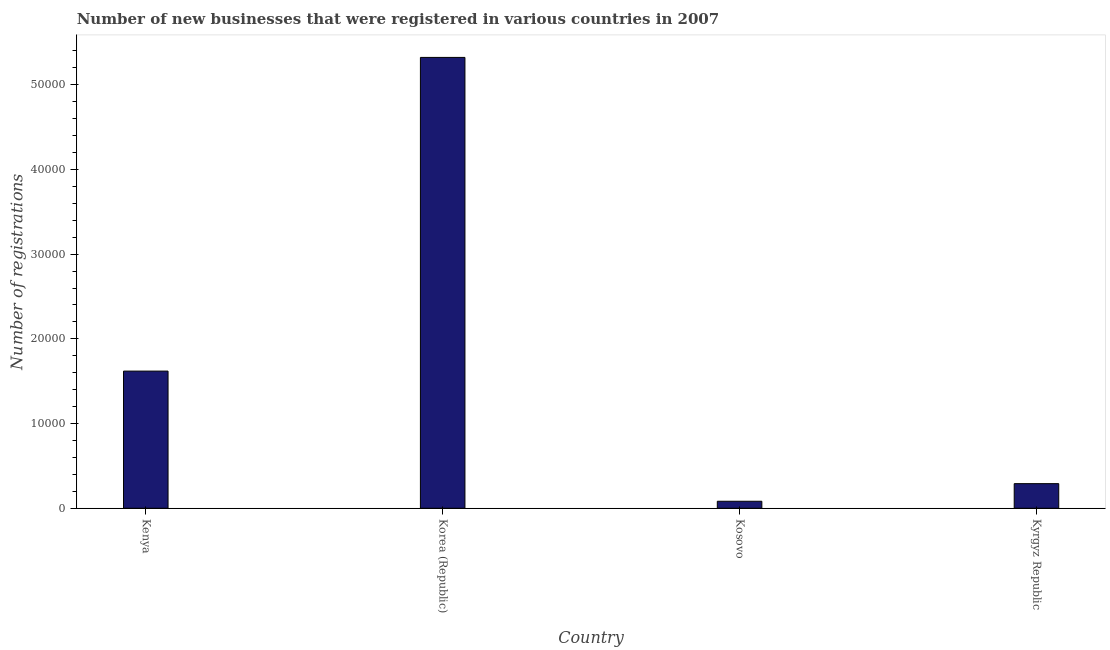What is the title of the graph?
Offer a terse response. Number of new businesses that were registered in various countries in 2007. What is the label or title of the X-axis?
Ensure brevity in your answer.  Country. What is the label or title of the Y-axis?
Give a very brief answer. Number of registrations. What is the number of new business registrations in Kenya?
Make the answer very short. 1.62e+04. Across all countries, what is the maximum number of new business registrations?
Your answer should be very brief. 5.32e+04. Across all countries, what is the minimum number of new business registrations?
Your answer should be very brief. 827. In which country was the number of new business registrations maximum?
Provide a short and direct response. Korea (Republic). In which country was the number of new business registrations minimum?
Provide a short and direct response. Kosovo. What is the sum of the number of new business registrations?
Your answer should be compact. 7.32e+04. What is the difference between the number of new business registrations in Korea (Republic) and Kyrgyz Republic?
Your response must be concise. 5.03e+04. What is the average number of new business registrations per country?
Make the answer very short. 1.83e+04. What is the median number of new business registrations?
Your answer should be compact. 9549.5. In how many countries, is the number of new business registrations greater than 6000 ?
Your answer should be very brief. 2. What is the ratio of the number of new business registrations in Kosovo to that in Kyrgyz Republic?
Offer a terse response. 0.28. Is the number of new business registrations in Kenya less than that in Kyrgyz Republic?
Your response must be concise. No. Is the difference between the number of new business registrations in Kenya and Korea (Republic) greater than the difference between any two countries?
Offer a terse response. No. What is the difference between the highest and the second highest number of new business registrations?
Provide a short and direct response. 3.70e+04. What is the difference between the highest and the lowest number of new business registrations?
Make the answer very short. 5.24e+04. How many bars are there?
Your response must be concise. 4. Are the values on the major ticks of Y-axis written in scientific E-notation?
Offer a very short reply. No. What is the Number of registrations of Kenya?
Your answer should be compact. 1.62e+04. What is the Number of registrations of Korea (Republic)?
Make the answer very short. 5.32e+04. What is the Number of registrations of Kosovo?
Your response must be concise. 827. What is the Number of registrations of Kyrgyz Republic?
Keep it short and to the point. 2906. What is the difference between the Number of registrations in Kenya and Korea (Republic)?
Give a very brief answer. -3.70e+04. What is the difference between the Number of registrations in Kenya and Kosovo?
Offer a very short reply. 1.54e+04. What is the difference between the Number of registrations in Kenya and Kyrgyz Republic?
Make the answer very short. 1.33e+04. What is the difference between the Number of registrations in Korea (Republic) and Kosovo?
Offer a terse response. 5.24e+04. What is the difference between the Number of registrations in Korea (Republic) and Kyrgyz Republic?
Offer a terse response. 5.03e+04. What is the difference between the Number of registrations in Kosovo and Kyrgyz Republic?
Your answer should be very brief. -2079. What is the ratio of the Number of registrations in Kenya to that in Korea (Republic)?
Offer a terse response. 0.3. What is the ratio of the Number of registrations in Kenya to that in Kosovo?
Your answer should be compact. 19.58. What is the ratio of the Number of registrations in Kenya to that in Kyrgyz Republic?
Offer a terse response. 5.57. What is the ratio of the Number of registrations in Korea (Republic) to that in Kosovo?
Provide a short and direct response. 64.36. What is the ratio of the Number of registrations in Korea (Republic) to that in Kyrgyz Republic?
Offer a terse response. 18.32. What is the ratio of the Number of registrations in Kosovo to that in Kyrgyz Republic?
Offer a very short reply. 0.28. 